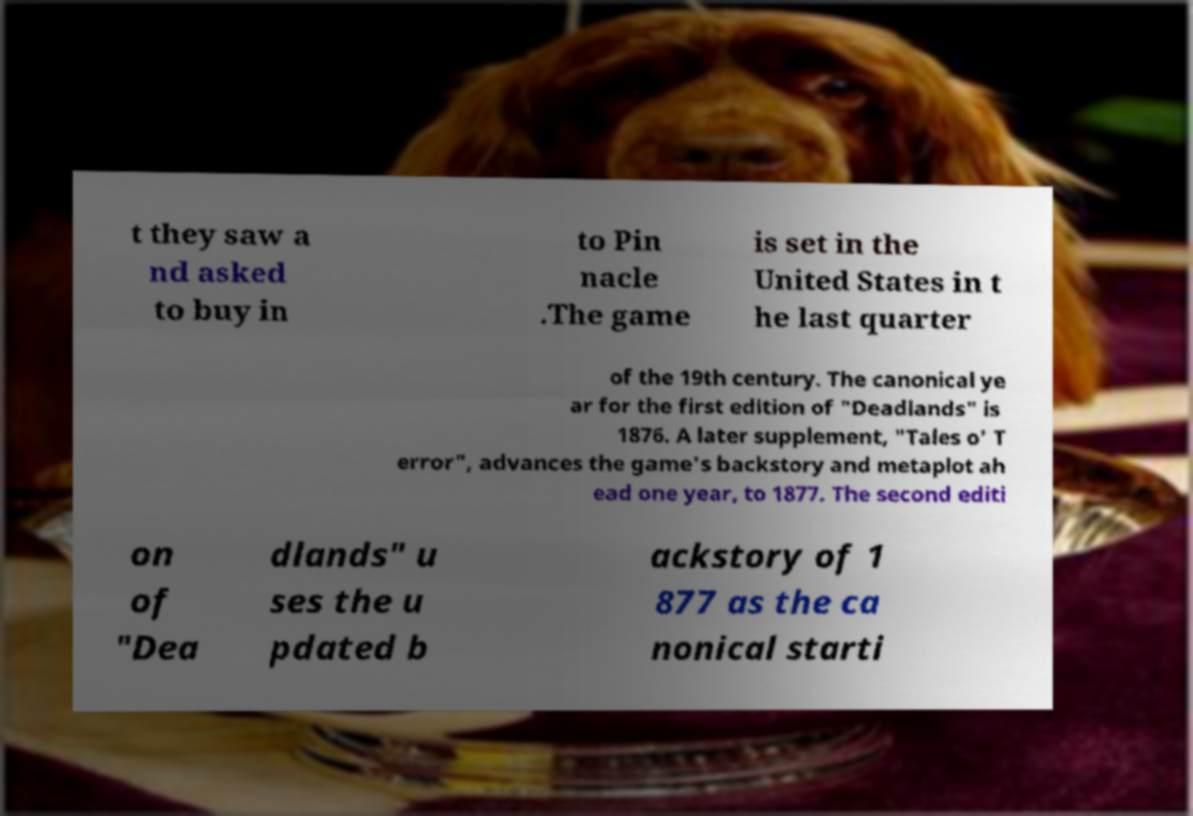Could you extract and type out the text from this image? t they saw a nd asked to buy in to Pin nacle .The game is set in the United States in t he last quarter of the 19th century. The canonical ye ar for the first edition of "Deadlands" is 1876. A later supplement, "Tales o' T error", advances the game's backstory and metaplot ah ead one year, to 1877. The second editi on of "Dea dlands" u ses the u pdated b ackstory of 1 877 as the ca nonical starti 